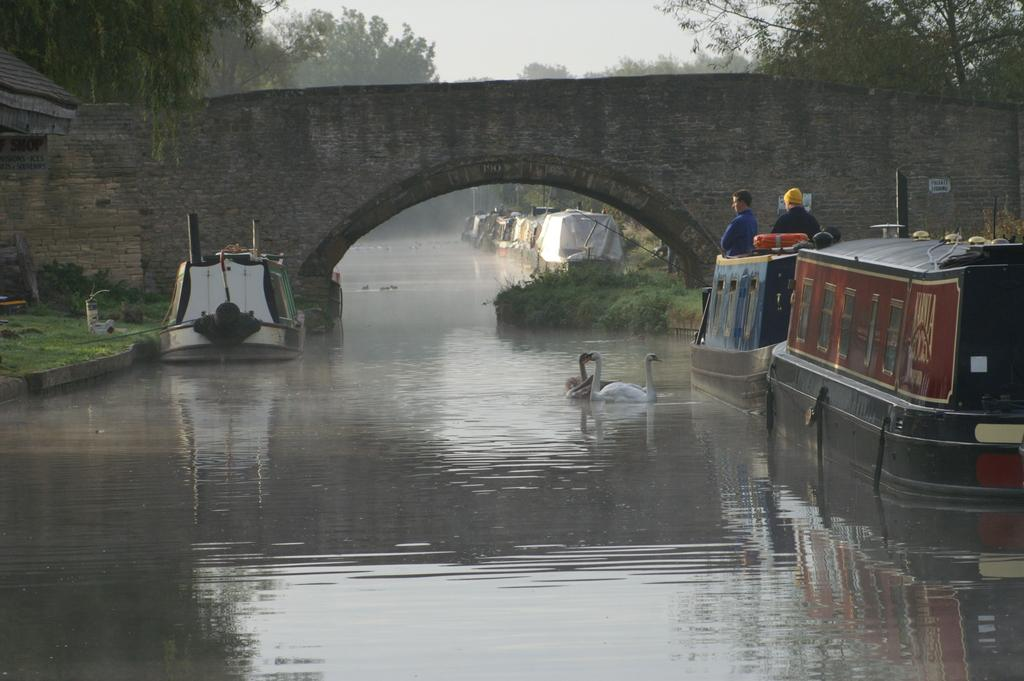How many people are in the image? There are people in the image, but the exact number is not specified. What structure can be seen in the image? There is an arch in the image. What type of animals are present in the image? There are ducks in the image. What type of vehicles are in the image? There are boats in the image. What type of vegetation is visible in the image? There are trees in the image. What natural element is visible in the image? Water is visible in the image. What part of the natural environment is visible in the image? The sky is visible in the image. What type of leaf is causing disgust in the image? There is no leaf present in the image, nor is there any indication of disgust. 